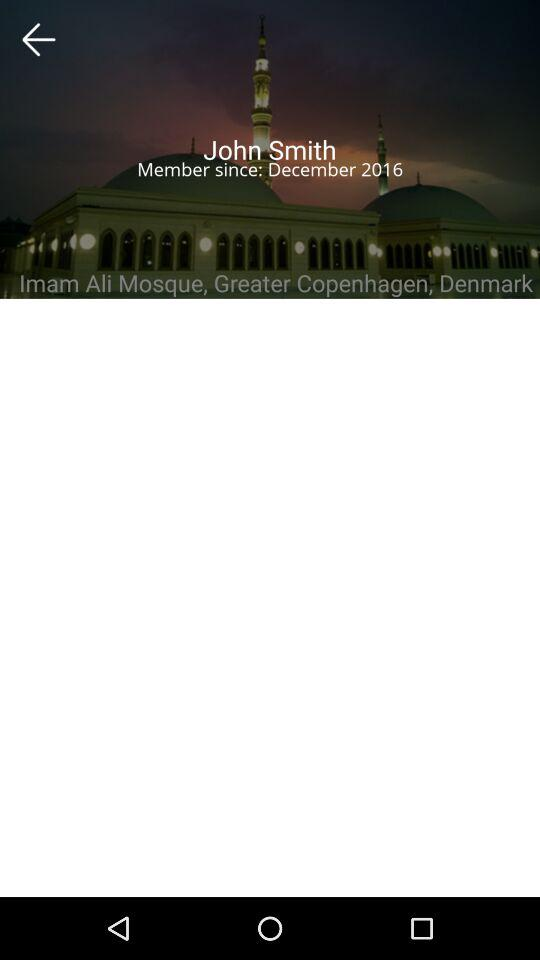What is the name of the user? The name of the user is John Smith. 